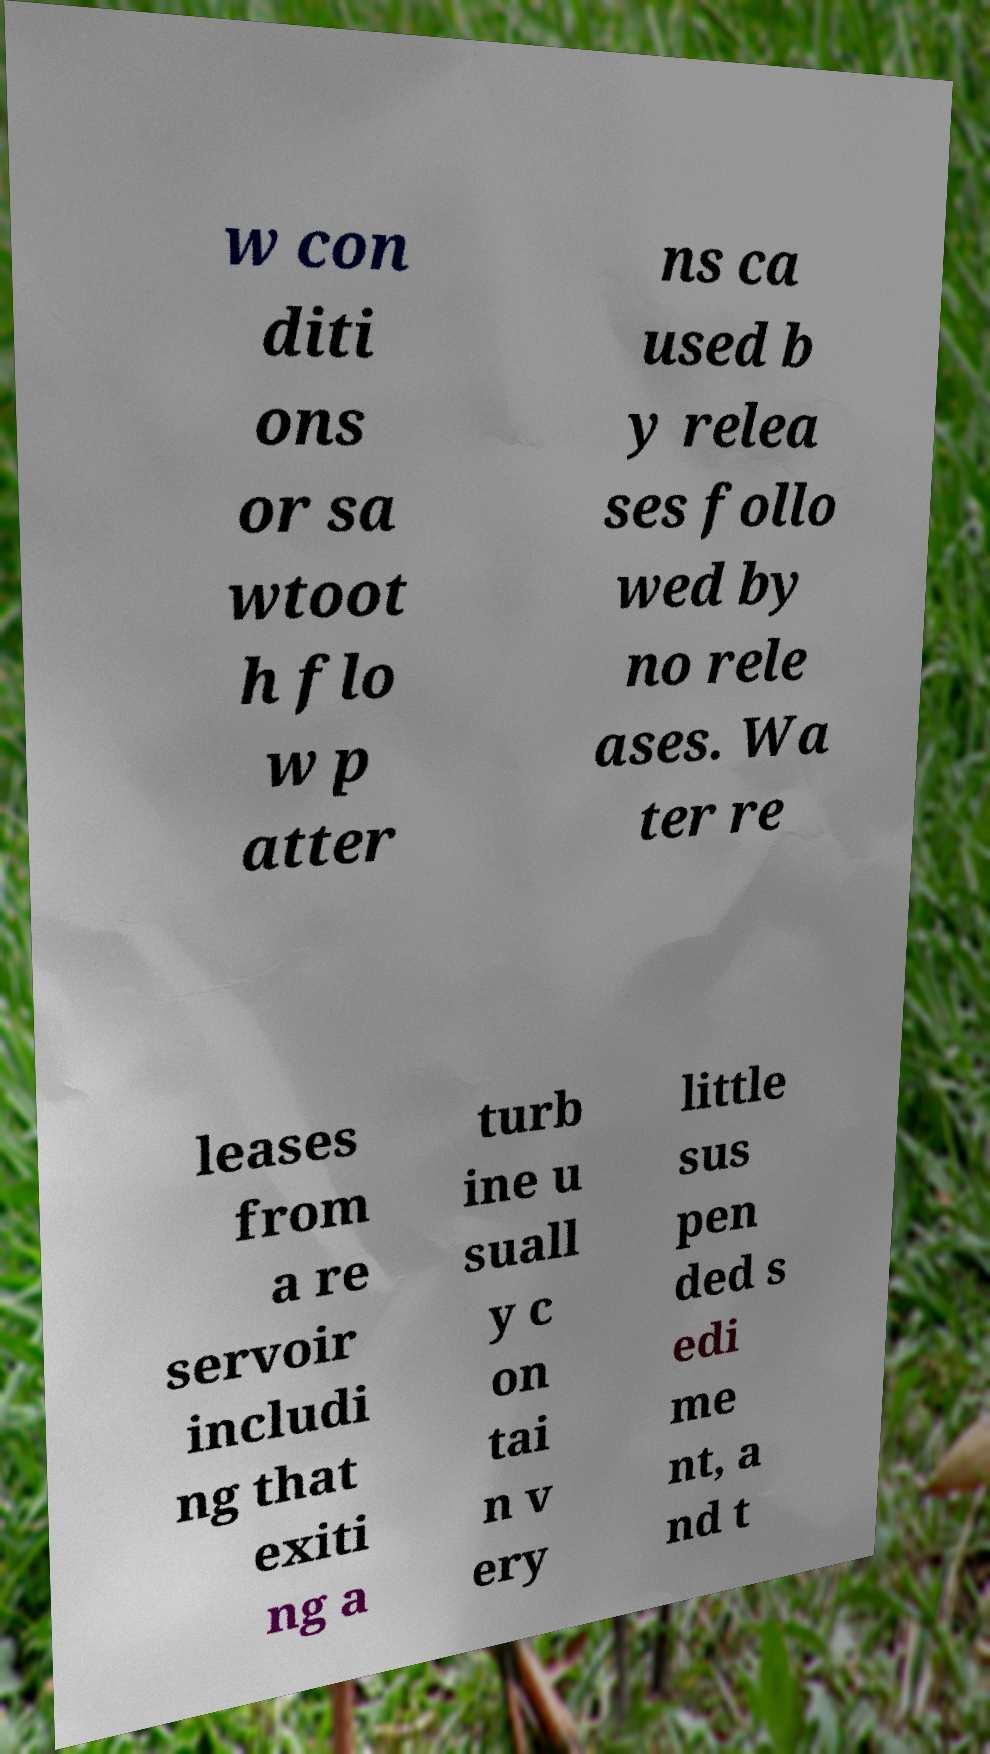Can you read and provide the text displayed in the image?This photo seems to have some interesting text. Can you extract and type it out for me? w con diti ons or sa wtoot h flo w p atter ns ca used b y relea ses follo wed by no rele ases. Wa ter re leases from a re servoir includi ng that exiti ng a turb ine u suall y c on tai n v ery little sus pen ded s edi me nt, a nd t 